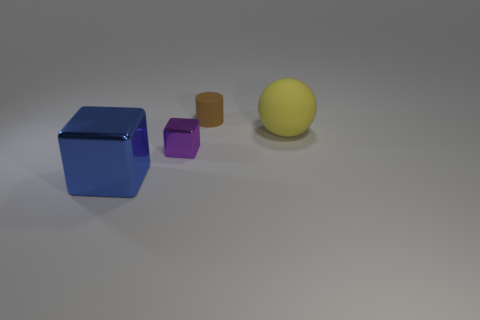Add 2 large red metal blocks. How many objects exist? 6 Subtract 0 red cylinders. How many objects are left? 4 Subtract 2 blocks. How many blocks are left? 0 Subtract all blue cubes. Subtract all blue cylinders. How many cubes are left? 1 Subtract all brown rubber objects. Subtract all purple shiny blocks. How many objects are left? 2 Add 2 blocks. How many blocks are left? 4 Add 3 big rubber cubes. How many big rubber cubes exist? 3 